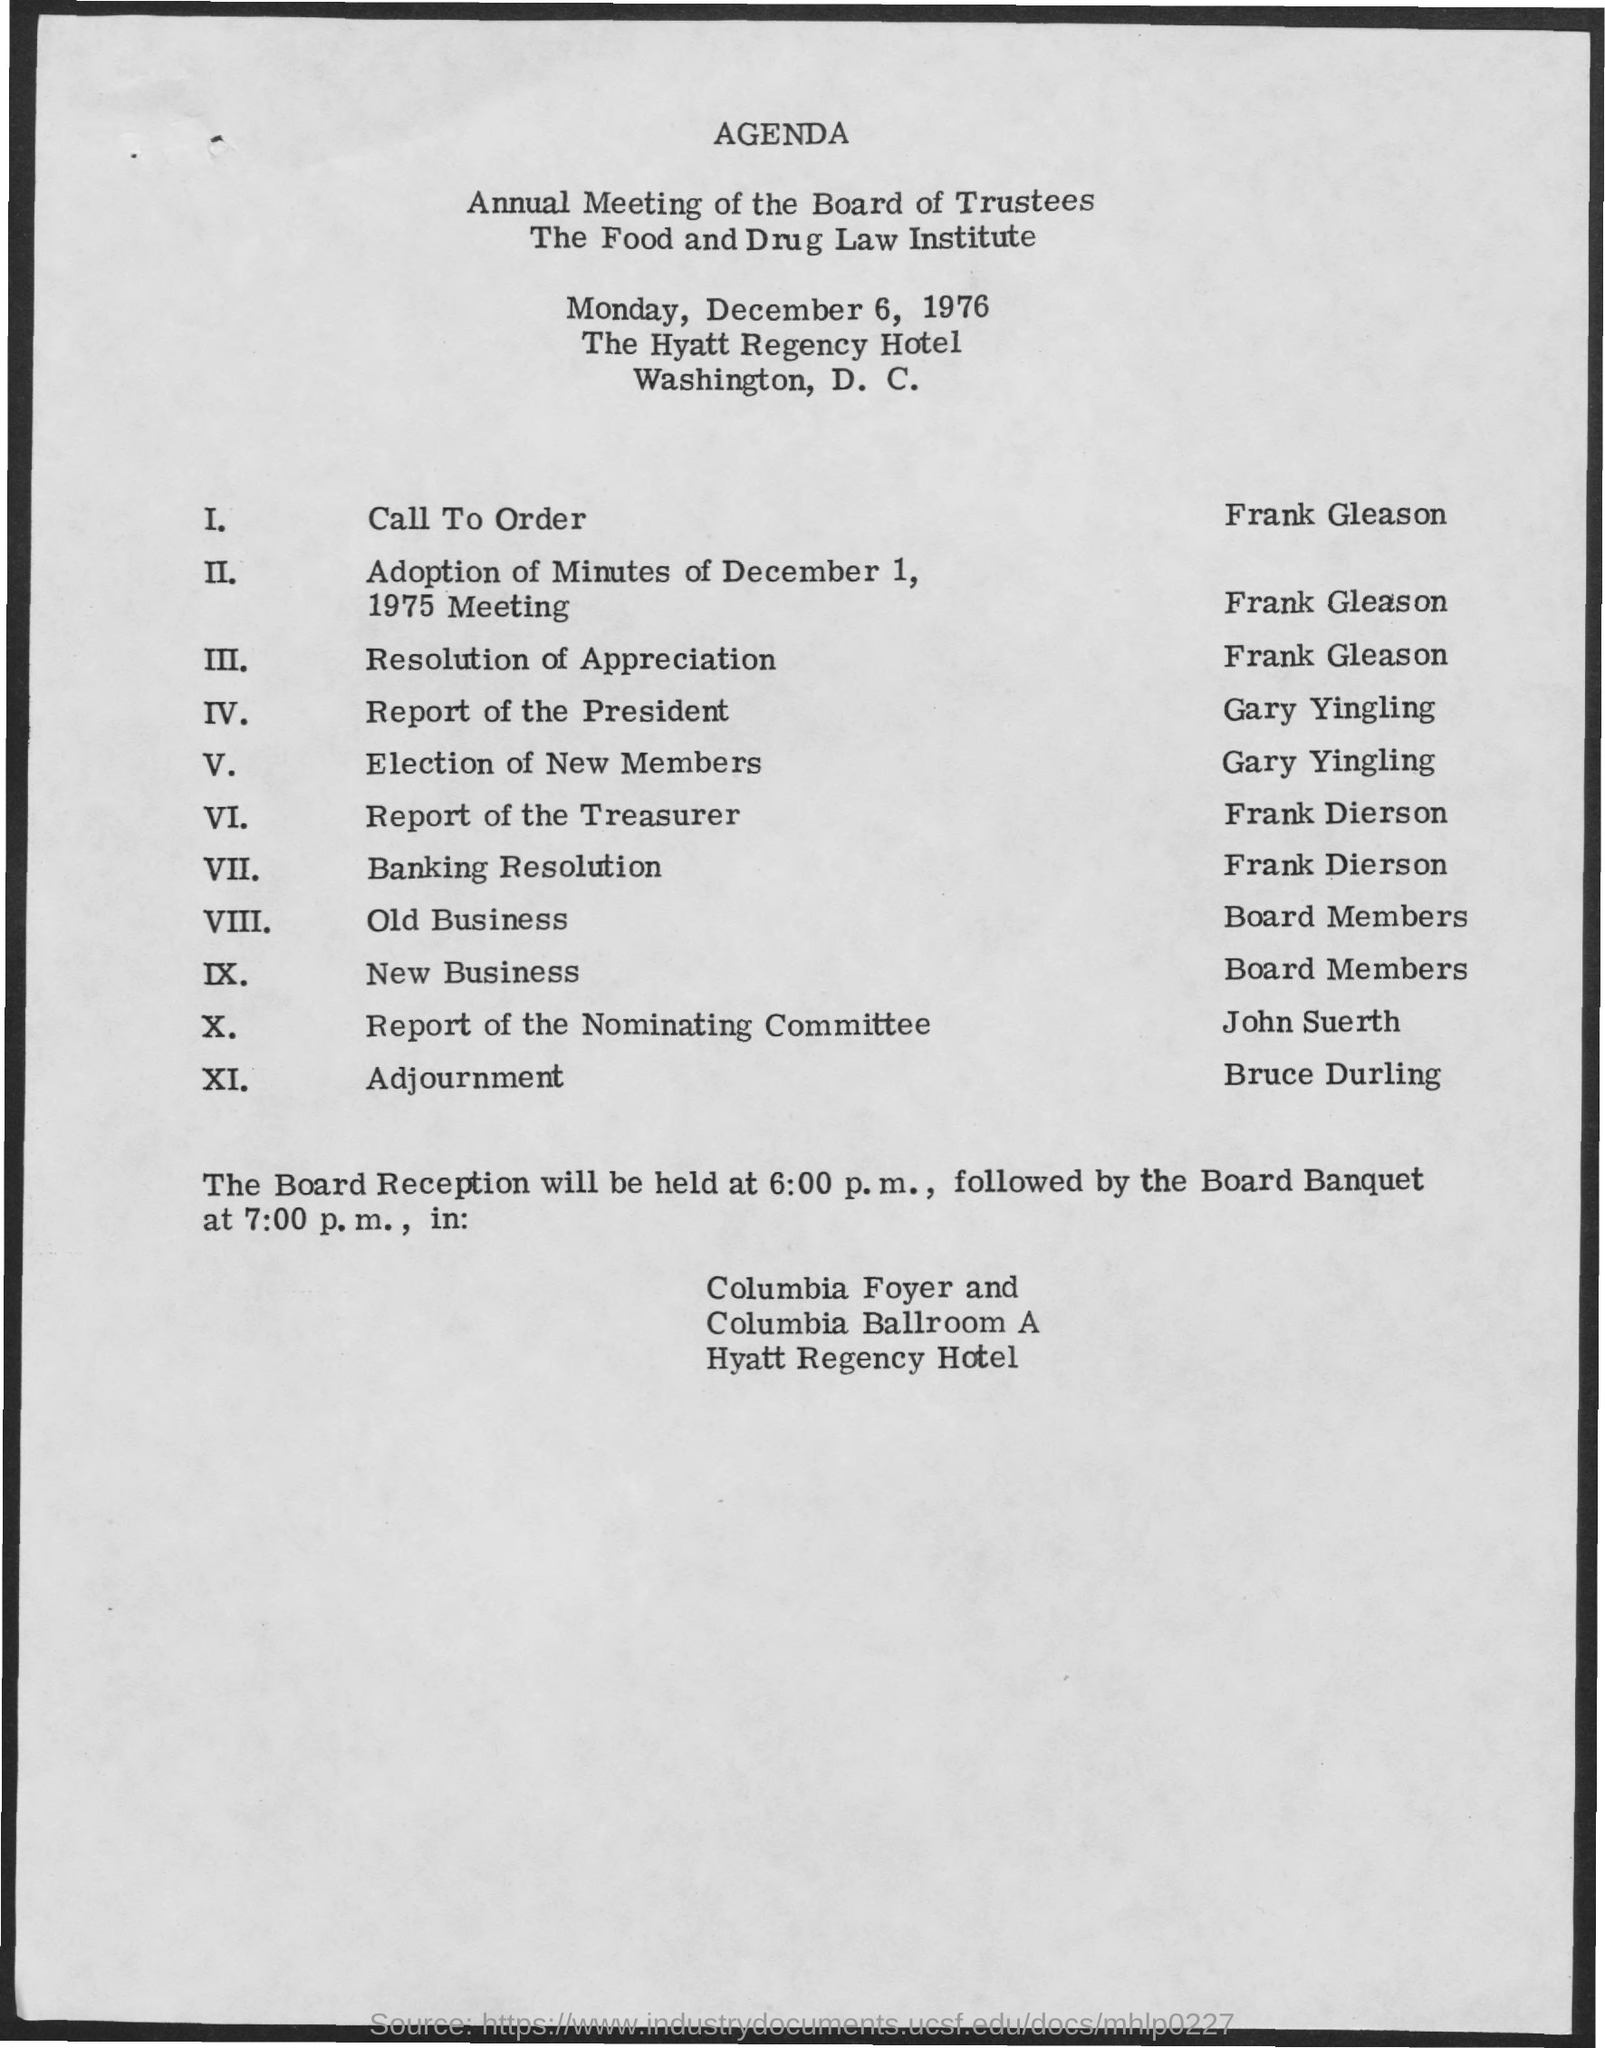What is the date scheduled for the annual meeting ?
Keep it short and to the point. December 6, 1976. In which hotel the meeting was scheduled ?
Provide a short and direct response. The Hyatt Regency Hotel. At what time the board reception is scheduled ?
Your response must be concise. 6:00 pm. At what time the board banquet is scheduled ?
Keep it short and to the point. 7:00 pm. 